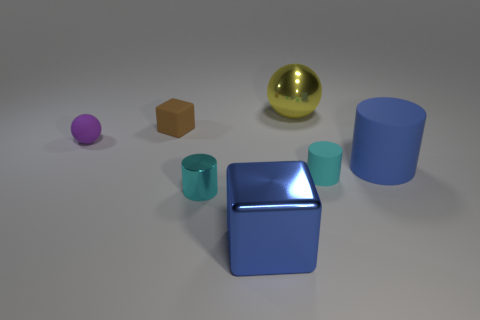Subtract all matte cylinders. How many cylinders are left? 1 Subtract all blue blocks. How many cyan cylinders are left? 2 Add 2 large yellow objects. How many objects exist? 9 Subtract all spheres. How many objects are left? 5 Subtract all big cubes. Subtract all large gray metal cylinders. How many objects are left? 6 Add 7 small cyan things. How many small cyan things are left? 9 Add 4 tiny blue matte cylinders. How many tiny blue matte cylinders exist? 4 Subtract 0 red cylinders. How many objects are left? 7 Subtract all gray cylinders. Subtract all blue balls. How many cylinders are left? 3 